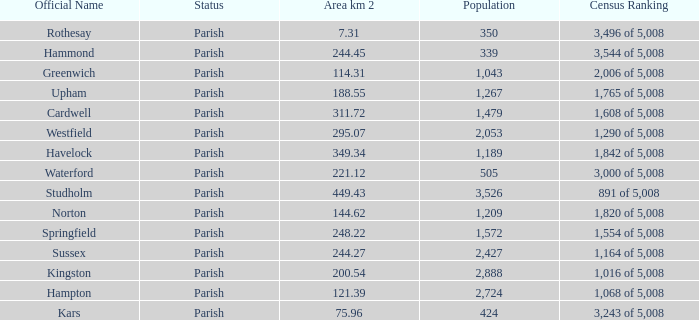What is the area in square kilometers of Studholm? 1.0. 